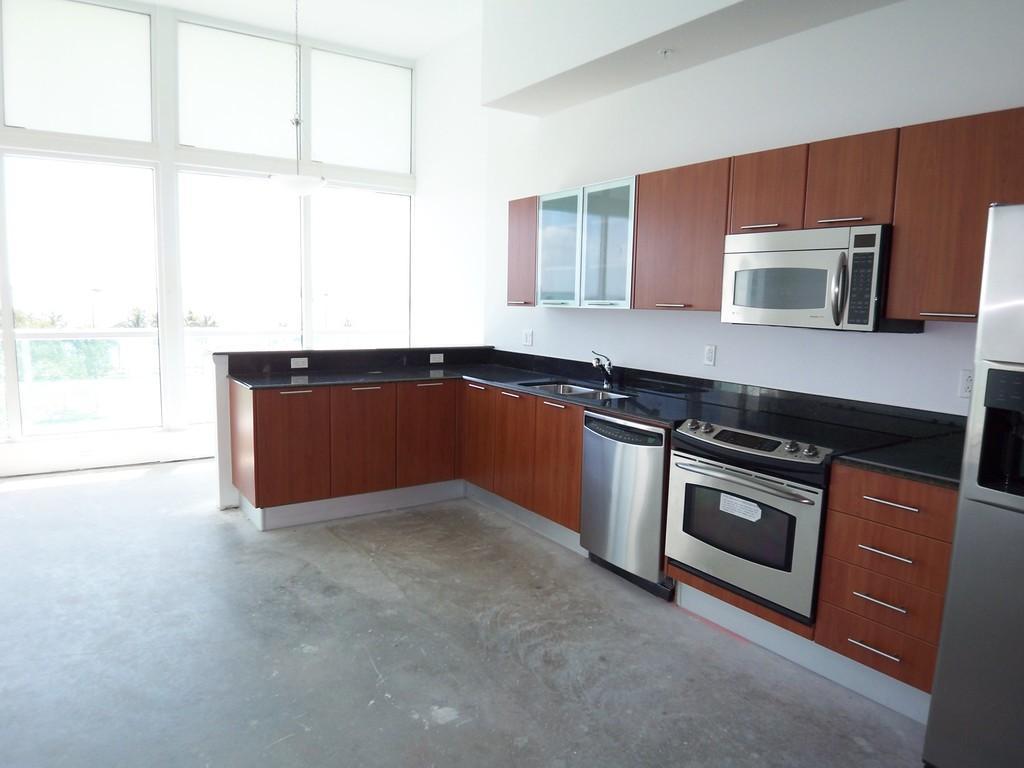Please provide a concise description of this image. This is an inside view of a kitchen. On the right side, I can see the table cabinets and refrigerator. At the top there are few cupboards and a micro oven. On the left side there is a glass through which we can see the outside view. 